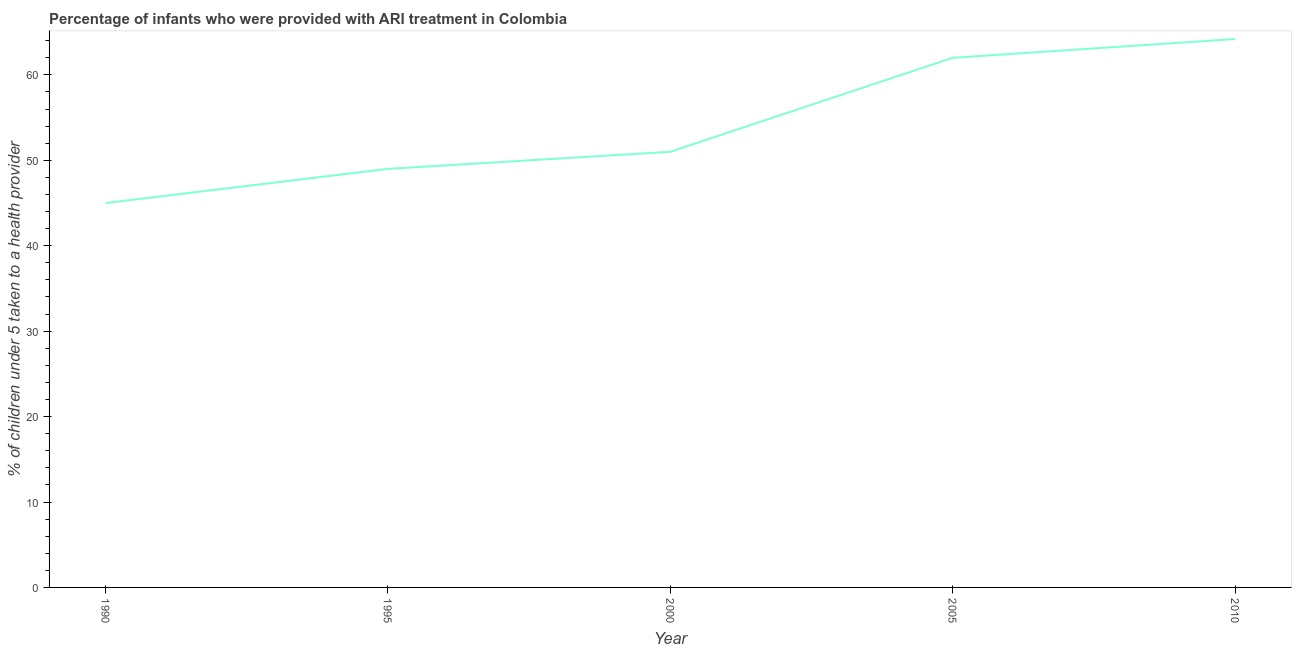What is the percentage of children who were provided with ari treatment in 2010?
Your response must be concise. 64.2. Across all years, what is the maximum percentage of children who were provided with ari treatment?
Keep it short and to the point. 64.2. Across all years, what is the minimum percentage of children who were provided with ari treatment?
Offer a terse response. 45. What is the sum of the percentage of children who were provided with ari treatment?
Offer a terse response. 271.2. What is the difference between the percentage of children who were provided with ari treatment in 1990 and 2010?
Ensure brevity in your answer.  -19.2. What is the average percentage of children who were provided with ari treatment per year?
Your response must be concise. 54.24. What is the median percentage of children who were provided with ari treatment?
Ensure brevity in your answer.  51. In how many years, is the percentage of children who were provided with ari treatment greater than 34 %?
Offer a terse response. 5. What is the ratio of the percentage of children who were provided with ari treatment in 1990 to that in 1995?
Provide a succinct answer. 0.92. Is the difference between the percentage of children who were provided with ari treatment in 1990 and 2010 greater than the difference between any two years?
Provide a short and direct response. Yes. What is the difference between the highest and the second highest percentage of children who were provided with ari treatment?
Ensure brevity in your answer.  2.2. What is the difference between the highest and the lowest percentage of children who were provided with ari treatment?
Your answer should be very brief. 19.2. Does the percentage of children who were provided with ari treatment monotonically increase over the years?
Offer a terse response. Yes. How many lines are there?
Give a very brief answer. 1. How many years are there in the graph?
Your response must be concise. 5. Are the values on the major ticks of Y-axis written in scientific E-notation?
Ensure brevity in your answer.  No. Does the graph contain any zero values?
Offer a very short reply. No. Does the graph contain grids?
Your answer should be compact. No. What is the title of the graph?
Provide a short and direct response. Percentage of infants who were provided with ARI treatment in Colombia. What is the label or title of the Y-axis?
Ensure brevity in your answer.  % of children under 5 taken to a health provider. What is the % of children under 5 taken to a health provider of 2000?
Your response must be concise. 51. What is the % of children under 5 taken to a health provider of 2010?
Offer a very short reply. 64.2. What is the difference between the % of children under 5 taken to a health provider in 1990 and 2000?
Keep it short and to the point. -6. What is the difference between the % of children under 5 taken to a health provider in 1990 and 2010?
Give a very brief answer. -19.2. What is the difference between the % of children under 5 taken to a health provider in 1995 and 2000?
Give a very brief answer. -2. What is the difference between the % of children under 5 taken to a health provider in 1995 and 2010?
Your answer should be compact. -15.2. What is the difference between the % of children under 5 taken to a health provider in 2000 and 2010?
Provide a succinct answer. -13.2. What is the difference between the % of children under 5 taken to a health provider in 2005 and 2010?
Provide a succinct answer. -2.2. What is the ratio of the % of children under 5 taken to a health provider in 1990 to that in 1995?
Provide a short and direct response. 0.92. What is the ratio of the % of children under 5 taken to a health provider in 1990 to that in 2000?
Ensure brevity in your answer.  0.88. What is the ratio of the % of children under 5 taken to a health provider in 1990 to that in 2005?
Give a very brief answer. 0.73. What is the ratio of the % of children under 5 taken to a health provider in 1990 to that in 2010?
Make the answer very short. 0.7. What is the ratio of the % of children under 5 taken to a health provider in 1995 to that in 2005?
Offer a very short reply. 0.79. What is the ratio of the % of children under 5 taken to a health provider in 1995 to that in 2010?
Ensure brevity in your answer.  0.76. What is the ratio of the % of children under 5 taken to a health provider in 2000 to that in 2005?
Your answer should be compact. 0.82. What is the ratio of the % of children under 5 taken to a health provider in 2000 to that in 2010?
Provide a succinct answer. 0.79. What is the ratio of the % of children under 5 taken to a health provider in 2005 to that in 2010?
Ensure brevity in your answer.  0.97. 